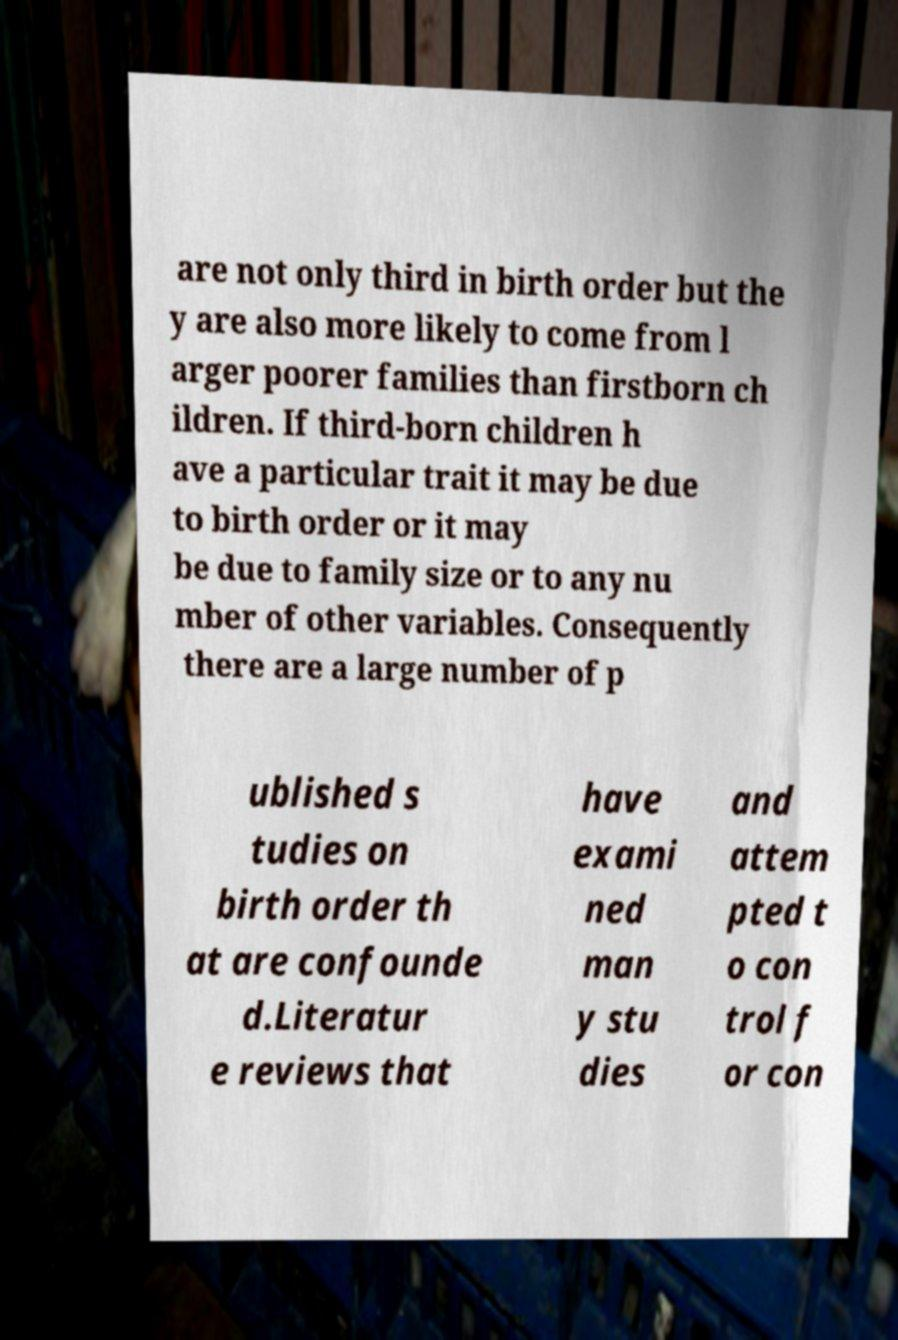Can you accurately transcribe the text from the provided image for me? are not only third in birth order but the y are also more likely to come from l arger poorer families than firstborn ch ildren. If third-born children h ave a particular trait it may be due to birth order or it may be due to family size or to any nu mber of other variables. Consequently there are a large number of p ublished s tudies on birth order th at are confounde d.Literatur e reviews that have exami ned man y stu dies and attem pted t o con trol f or con 